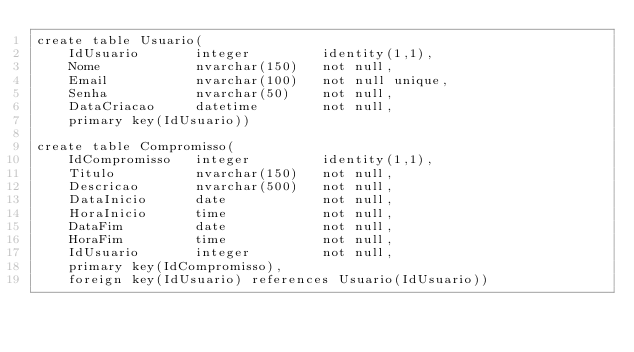<code> <loc_0><loc_0><loc_500><loc_500><_SQL_>create table Usuario(
	IdUsuario		integer			identity(1,1),
	Nome			nvarchar(150)	not null,
	Email			nvarchar(100)	not null unique,
	Senha			nvarchar(50)	not null,
	DataCriacao		datetime		not null,
	primary key(IdUsuario))

create table Compromisso(
	IdCompromisso	integer			identity(1,1),
	Titulo			nvarchar(150)	not null,
	Descricao		nvarchar(500)	not null,
	DataInicio		date			not null,
	HoraInicio		time			not null,
	DataFim			date			not null,
	HoraFim			time			not null,
	IdUsuario		integer			not null,
	primary key(IdCompromisso),
	foreign key(IdUsuario) references Usuario(IdUsuario))</code> 